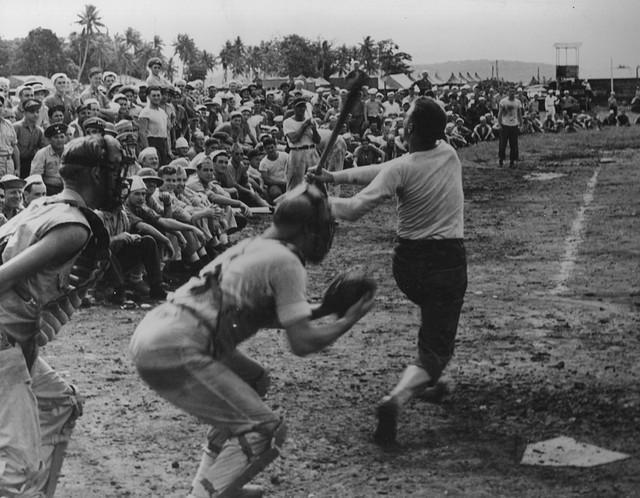How many men are playing baseball?
Give a very brief answer. 3. How many people can be seen?
Give a very brief answer. 5. 